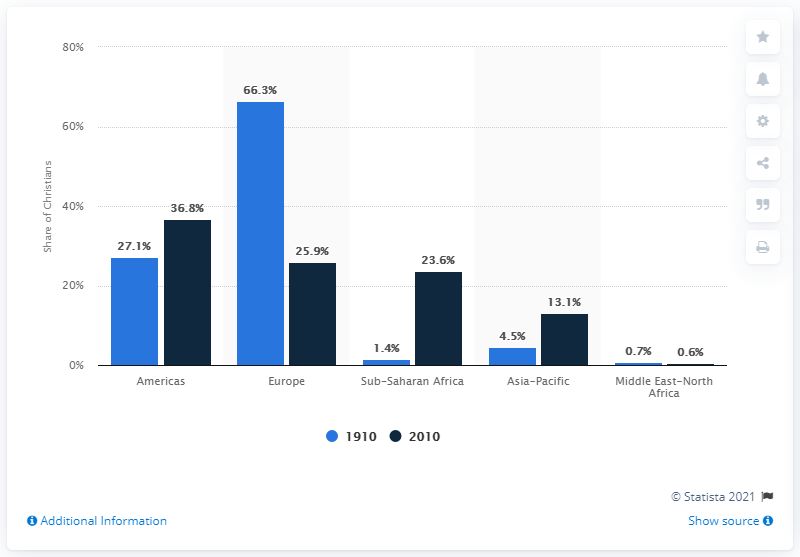List a handful of essential elements in this visual. In 1910, approximately 66.3% of Christians worldwide lived in Europe. 